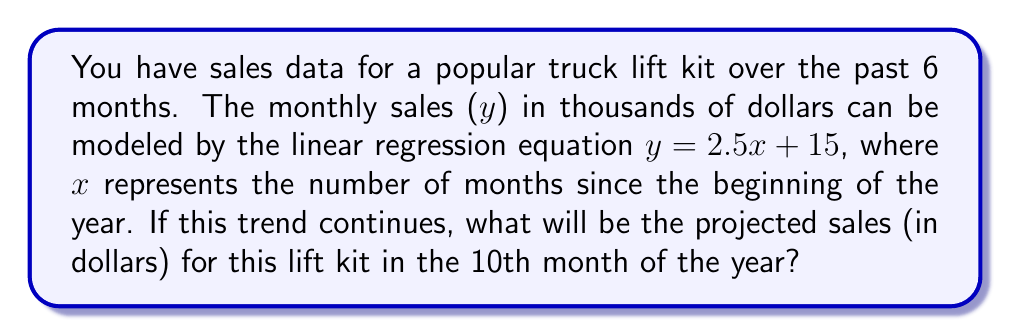Teach me how to tackle this problem. Let's approach this step-by-step:

1) We are given the linear regression equation: $y = 2.5x + 15$

   Where:
   - $y$ is the sales in thousands of dollars
   - $x$ is the number of months since the beginning of the year

2) We need to find the sales for the 10th month, so we'll substitute $x = 10$ into our equation:

   $y = 2.5(10) + 15$

3) Let's solve this:
   
   $y = 25 + 15 = 40$

4) Remember, this result is in thousands of dollars. To get the actual dollar amount, we need to multiply by 1000:

   $40 * 1000 = 40,000$

Therefore, the projected sales for the 10th month will be $40,000.
Answer: $40,000 